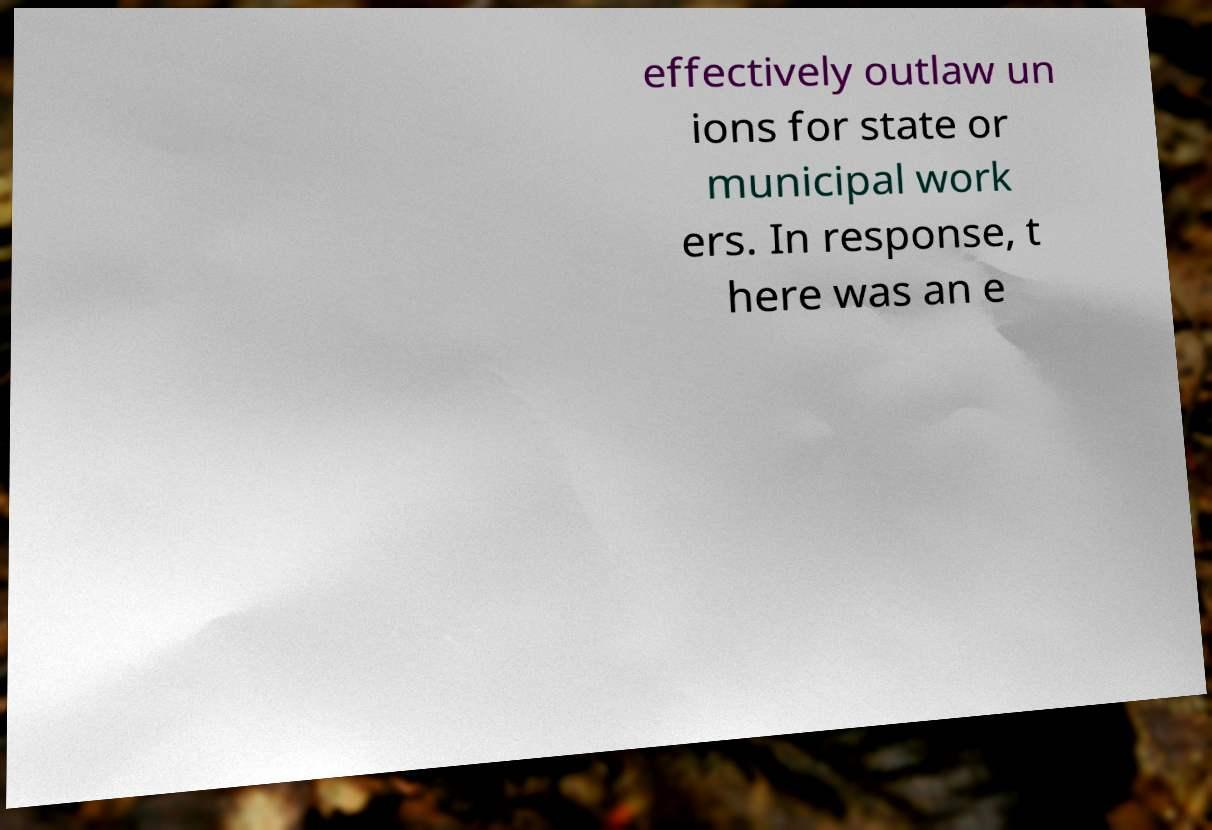I need the written content from this picture converted into text. Can you do that? effectively outlaw un ions for state or municipal work ers. In response, t here was an e 